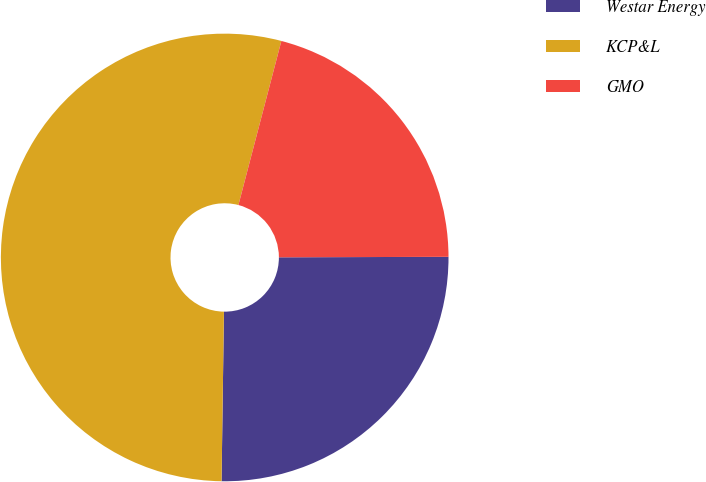Convert chart. <chart><loc_0><loc_0><loc_500><loc_500><pie_chart><fcel>Westar Energy<fcel>KCP&L<fcel>GMO<nl><fcel>25.27%<fcel>53.85%<fcel>20.88%<nl></chart> 